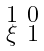Convert formula to latex. <formula><loc_0><loc_0><loc_500><loc_500>\begin{smallmatrix} 1 & 0 \\ \xi & 1 \end{smallmatrix}</formula> 